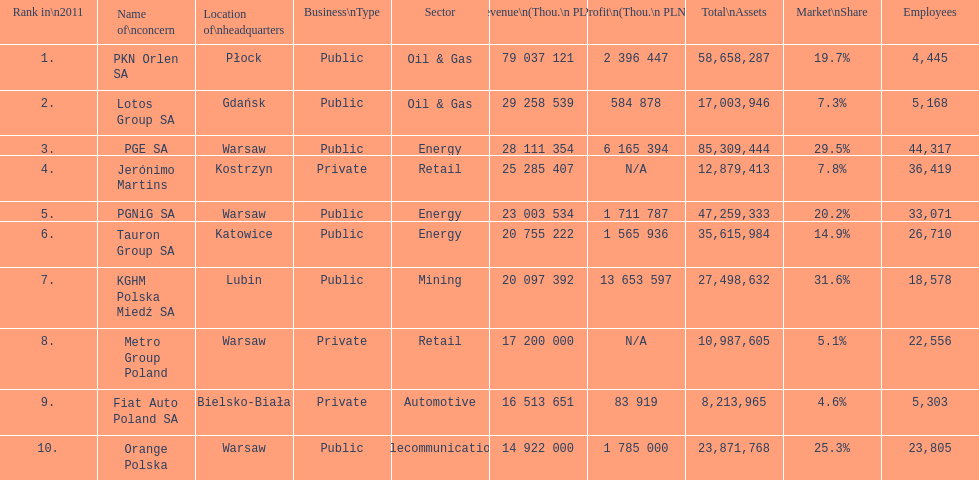Help me parse the entirety of this table. {'header': ['Rank in\\n2011', 'Name of\\nconcern', 'Location of\\nheadquarters', 'Business\\nType', 'Sector', 'Revenue\\n(Thou.\\n\xa0PLN)', 'Profit\\n(Thou.\\n\xa0PLN)', 'Total\\nAssets', 'Market\\nShare', 'Employees'], 'rows': [['1.', 'PKN Orlen SA', 'Płock', 'Public', 'Oil & Gas', '79 037 121', '2 396 447', '58,658,287', '19.7%', '4,445'], ['2.', 'Lotos Group SA', 'Gdańsk', 'Public', 'Oil & Gas', '29 258 539', '584 878', '17,003,946', '7.3%', '5,168'], ['3.', 'PGE SA', 'Warsaw', 'Public', 'Energy', '28 111 354', '6 165 394', '85,309,444', '29.5%', '44,317'], ['4.', 'Jerónimo Martins', 'Kostrzyn', 'Private', 'Retail', '25 285 407', 'N/A', '12,879,413', '7.8%', '36,419'], ['5.', 'PGNiG SA', 'Warsaw', 'Public', 'Energy', '23 003 534', '1 711 787', '47,259,333', '20.2%', '33,071'], ['6.', 'Tauron Group SA', 'Katowice', 'Public', 'Energy', '20 755 222', '1 565 936', '35,615,984', '14.9%', '26,710'], ['7.', 'KGHM Polska Miedź SA', 'Lubin', 'Public', 'Mining', '20 097 392', '13 653 597', '27,498,632', '31.6%', '18,578'], ['8.', 'Metro Group Poland', 'Warsaw', 'Private', 'Retail', '17 200 000', 'N/A', '10,987,605', '5.1%', '22,556'], ['9.', 'Fiat Auto Poland SA', 'Bielsko-Biała', 'Private', 'Automotive', '16 513 651', '83 919', '8,213,965', '4.6%', '5,303'], ['10.', 'Orange Polska', 'Warsaw', 'Public', 'Telecommunications', '14 922 000', '1 785 000', '23,871,768', '25.3%', '23,805']]} Which organization employs the most people? PGE SA. 